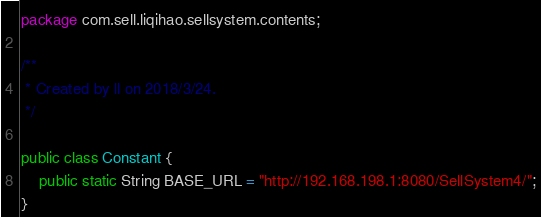Convert code to text. <code><loc_0><loc_0><loc_500><loc_500><_Java_>package com.sell.liqihao.sellsystem.contents;

/**
 * Created by ll on 2018/3/24.
 */

public class Constant {
    public static String BASE_URL = "http://192.168.198.1:8080/SellSystem4/";
}
</code> 